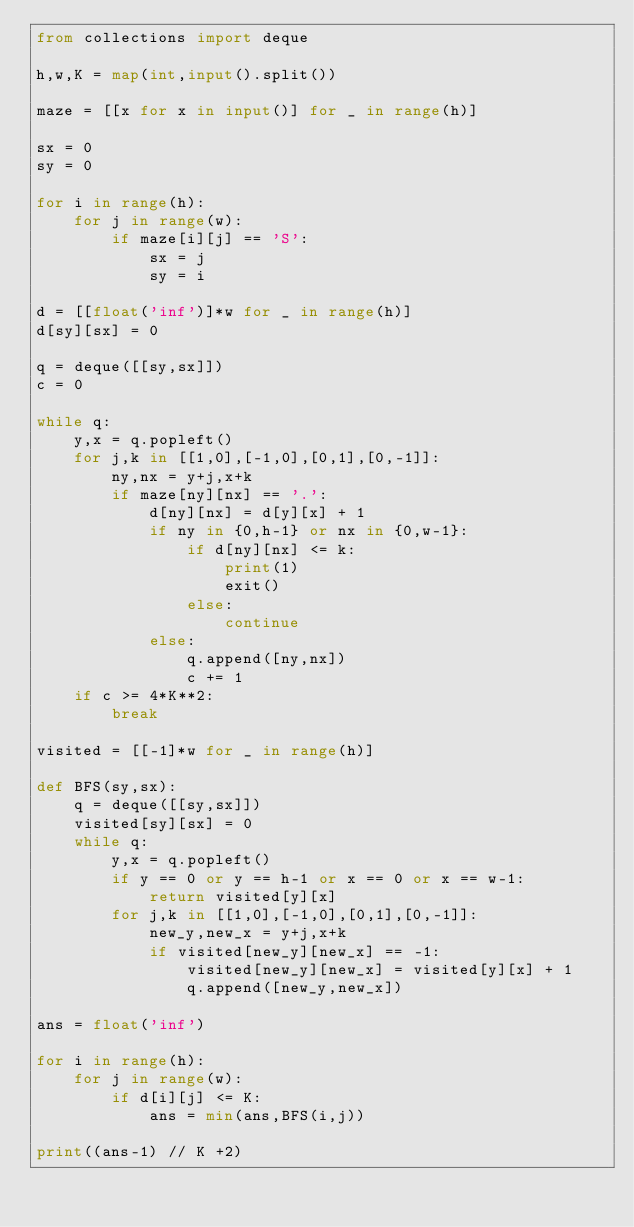Convert code to text. <code><loc_0><loc_0><loc_500><loc_500><_Python_>from collections import deque

h,w,K = map(int,input().split())

maze = [[x for x in input()] for _ in range(h)]

sx = 0
sy = 0

for i in range(h):
    for j in range(w):
        if maze[i][j] == 'S':
            sx = j
            sy = i

d = [[float('inf')]*w for _ in range(h)]
d[sy][sx] = 0

q = deque([[sy,sx]])
c = 0

while q:
    y,x = q.popleft()
    for j,k in [[1,0],[-1,0],[0,1],[0,-1]]:
        ny,nx = y+j,x+k
        if maze[ny][nx] == '.':
            d[ny][nx] = d[y][x] + 1
            if ny in {0,h-1} or nx in {0,w-1}:
                if d[ny][nx] <= k:
                    print(1)
                    exit()
                else:
                    continue
            else:
                q.append([ny,nx])
                c += 1
    if c >= 4*K**2:
        break
    
visited = [[-1]*w for _ in range(h)]

def BFS(sy,sx):
    q = deque([[sy,sx]])
    visited[sy][sx] = 0
    while q:
        y,x = q.popleft()
        if y == 0 or y == h-1 or x == 0 or x == w-1:
            return visited[y][x]
        for j,k in [[1,0],[-1,0],[0,1],[0,-1]]:
            new_y,new_x = y+j,x+k
            if visited[new_y][new_x] == -1:
                visited[new_y][new_x] = visited[y][x] + 1
                q.append([new_y,new_x])

ans = float('inf')

for i in range(h):
    for j in range(w):
        if d[i][j] <= K:
            ans = min(ans,BFS(i,j))

print((ans-1) // K +2)</code> 